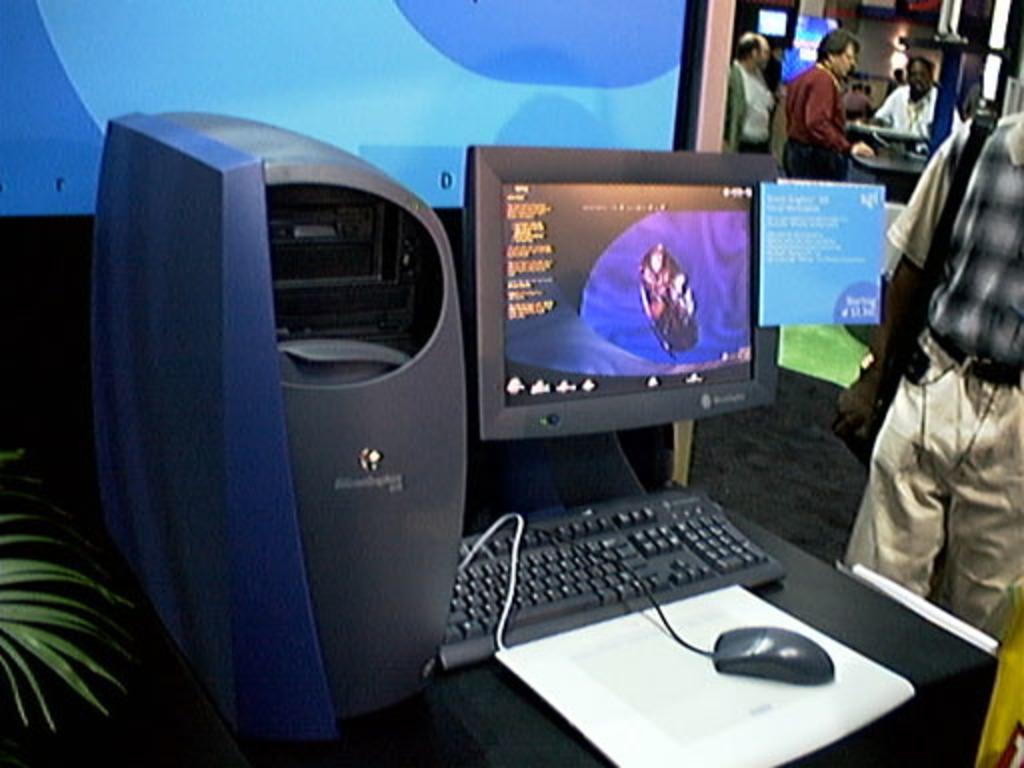Please provide a concise description of this image. In the image I can see a table on which there is a screen, mouse, keyboard and also I can see some other people to the side. 